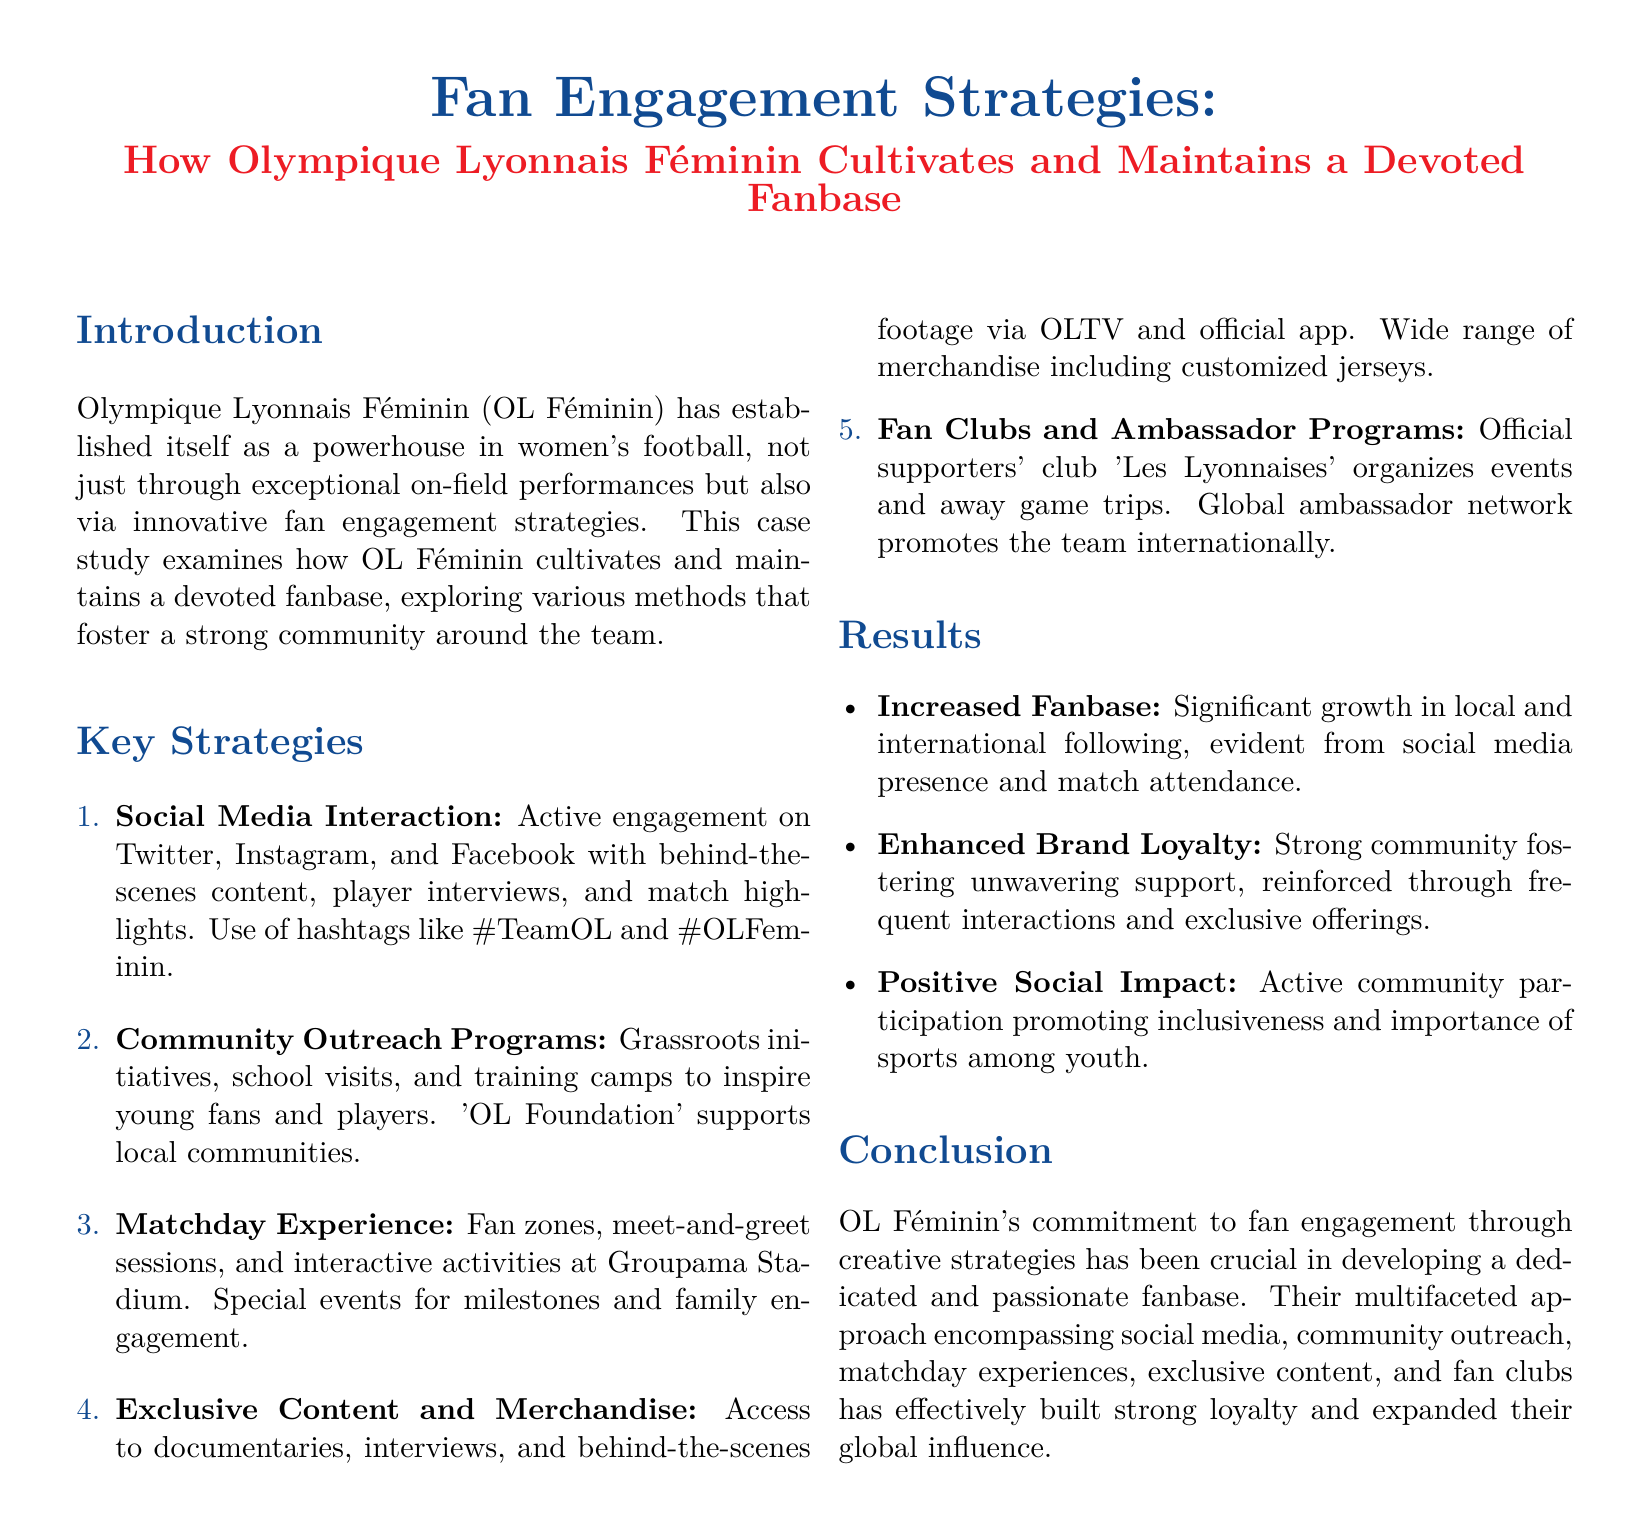what is OL Féminin's primary method for engaging fans? The document states that OL Féminin primarily engages fans through social media interaction.
Answer: Social Media Interaction what hashtag is commonly used by OL Féminin? The document mentions the hashtags used, which include #TeamOL and #OLFeminin.
Answer: #TeamOL, #OLFeminin what initiative supports local communities associated with OL Féminin? The document refers to the 'OL Foundation' as the initiative that supports local communities.
Answer: OL Foundation how many key strategies does OL Féminin employ for fan engagement? The document lists a total of five key strategies for fan engagement.
Answer: 5 what is a special event mentioned that enhances the matchday experience? The document highlights meet-and-greet sessions as a special event that enhances the matchday experience.
Answer: Meet-and-greet sessions which program connects OL Féminin fans internationally? The document describes a global ambassador network that promotes the team internationally.
Answer: Global ambassador network what is one outcome of OL Féminin's fan engagement strategies? The document states that a significant outcome is the increased fanbase, reflected in social media presence and match attendance.
Answer: Increased fanbase which fan club organizes events and away game trips? The document mentions the official supporters' club 'Les Lyonnaises' as the organizer of events and away game trips.
Answer: Les Lyonnaises what type of content is provided through OLTV? The document specifies that OLTV provides access to documentaries, interviews, and behind-the-scenes footage.
Answer: Documentaries, interviews, behind-the-scenes footage 